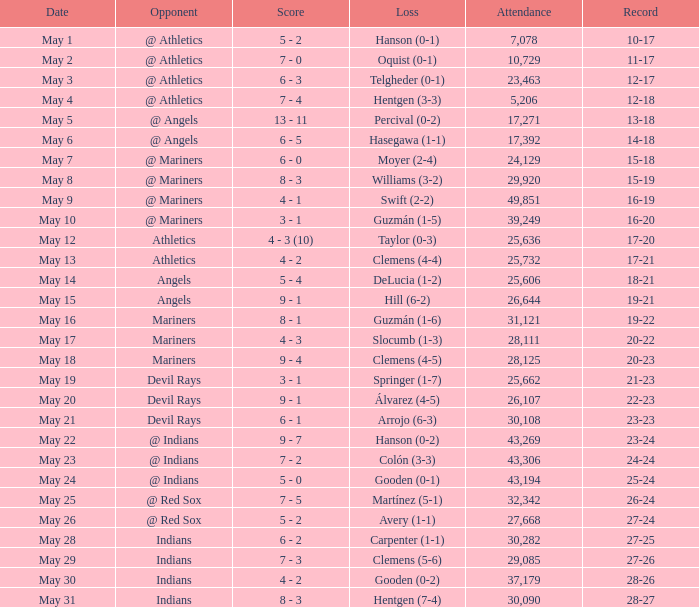When the record is 16-20 and attendance is greater than 32,342, what is the score? 3 - 1. 